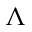Convert formula to latex. <formula><loc_0><loc_0><loc_500><loc_500>\Lambda</formula> 